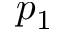Convert formula to latex. <formula><loc_0><loc_0><loc_500><loc_500>p _ { 1 }</formula> 